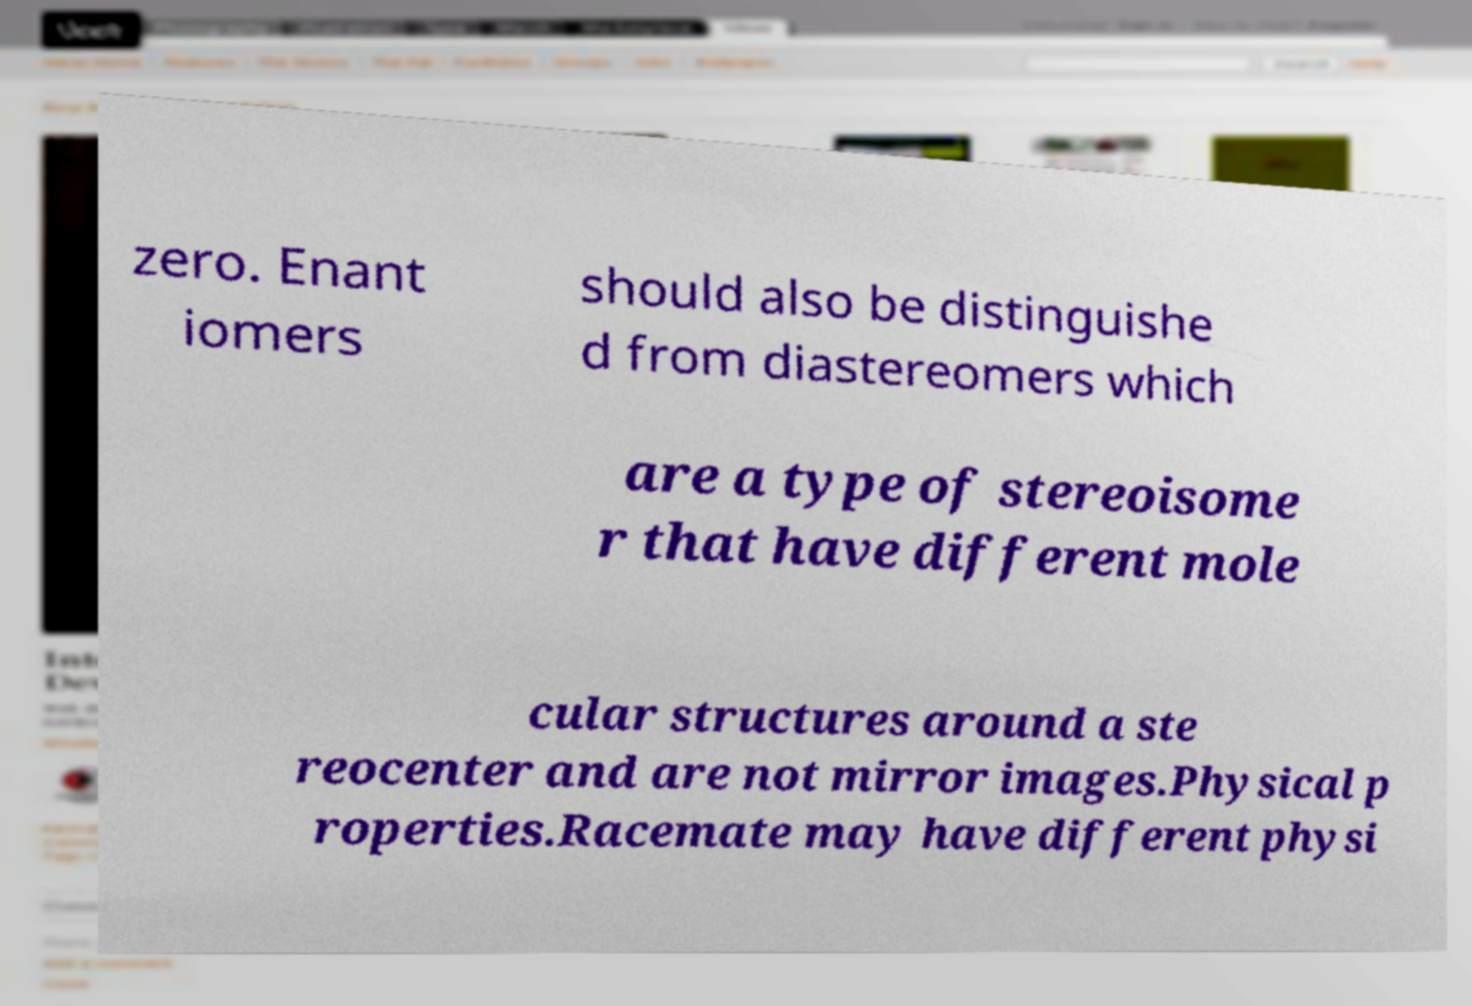I need the written content from this picture converted into text. Can you do that? zero. Enant iomers should also be distinguishe d from diastereomers which are a type of stereoisome r that have different mole cular structures around a ste reocenter and are not mirror images.Physical p roperties.Racemate may have different physi 